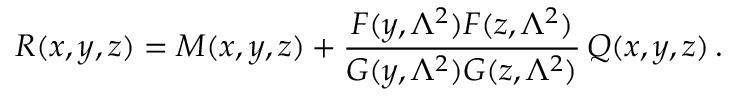Convert formula to latex. <formula><loc_0><loc_0><loc_500><loc_500>R ( x , y , z ) = M ( x , y , z ) + \frac { F ( y , \Lambda ^ { 2 } ) F ( z , \Lambda ^ { 2 } ) } { G ( y , \Lambda ^ { 2 } ) G ( z , \Lambda ^ { 2 } ) } \, Q ( x , y , z ) \, .</formula> 